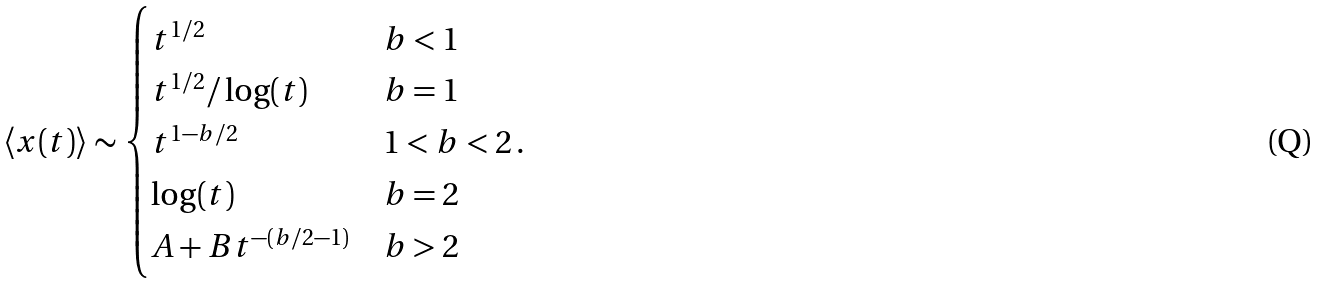<formula> <loc_0><loc_0><loc_500><loc_500>\left < x ( t ) \right > \sim \begin{cases} t ^ { 1 / 2 } & b < 1 \\ t ^ { 1 / 2 } / \log ( t ) & b = 1 \\ t ^ { 1 - b / 2 } & 1 < b < 2 \, . \\ \log ( t ) & b = 2 \\ A + B t ^ { - ( b / 2 - 1 ) } & b > 2 \end{cases}</formula> 